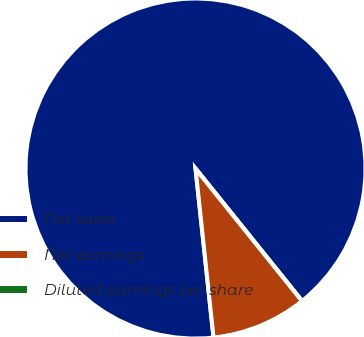Convert chart. <chart><loc_0><loc_0><loc_500><loc_500><pie_chart><fcel>Net sales<fcel>Net earnings<fcel>Diluted earnings per share<nl><fcel>90.91%<fcel>9.09%<fcel>0.0%<nl></chart> 